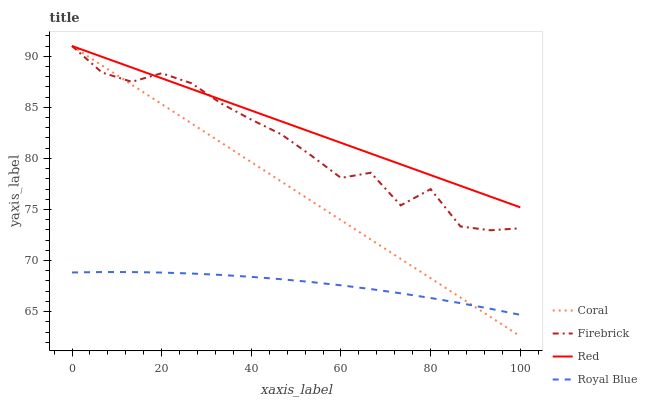Does Royal Blue have the minimum area under the curve?
Answer yes or no. Yes. Does Red have the maximum area under the curve?
Answer yes or no. Yes. Does Coral have the minimum area under the curve?
Answer yes or no. No. Does Coral have the maximum area under the curve?
Answer yes or no. No. Is Coral the smoothest?
Answer yes or no. Yes. Is Firebrick the roughest?
Answer yes or no. Yes. Is Firebrick the smoothest?
Answer yes or no. No. Is Coral the roughest?
Answer yes or no. No. Does Firebrick have the lowest value?
Answer yes or no. No. Does Red have the highest value?
Answer yes or no. Yes. Is Royal Blue less than Red?
Answer yes or no. Yes. Is Red greater than Royal Blue?
Answer yes or no. Yes. Does Royal Blue intersect Red?
Answer yes or no. No. 